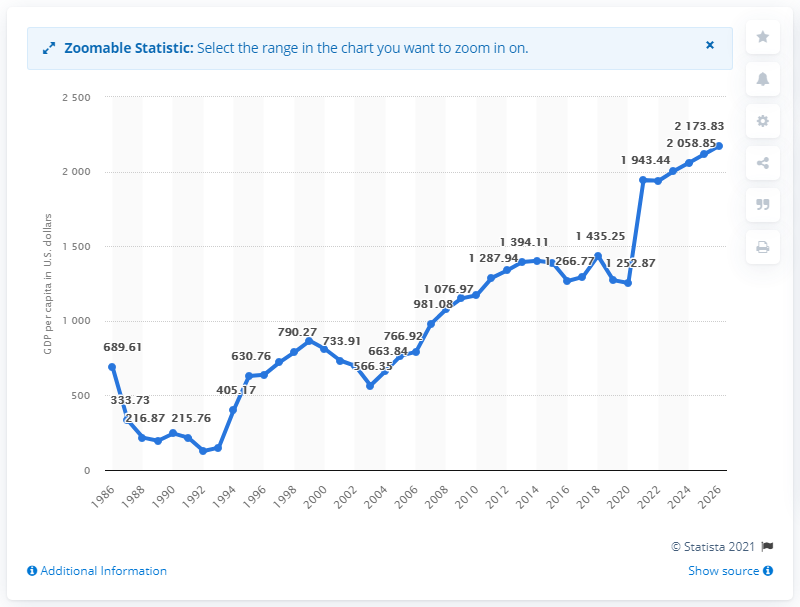Give some essential details in this illustration. The Gross Domestic Product (GDP) of Haiti is projected to reach a certain point by the year 2026. 